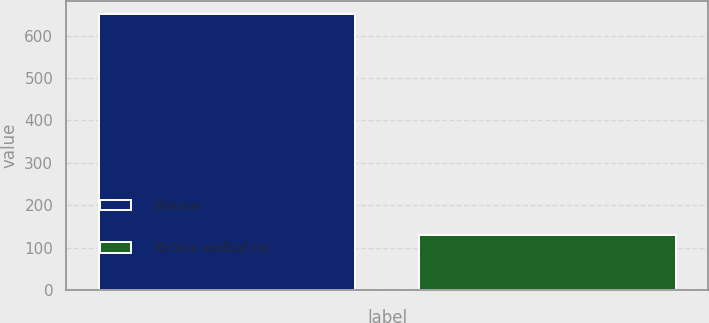Convert chart to OTSL. <chart><loc_0><loc_0><loc_500><loc_500><bar_chart><fcel>Pension<fcel>Retiree medical (a)<nl><fcel>650<fcel>130<nl></chart> 